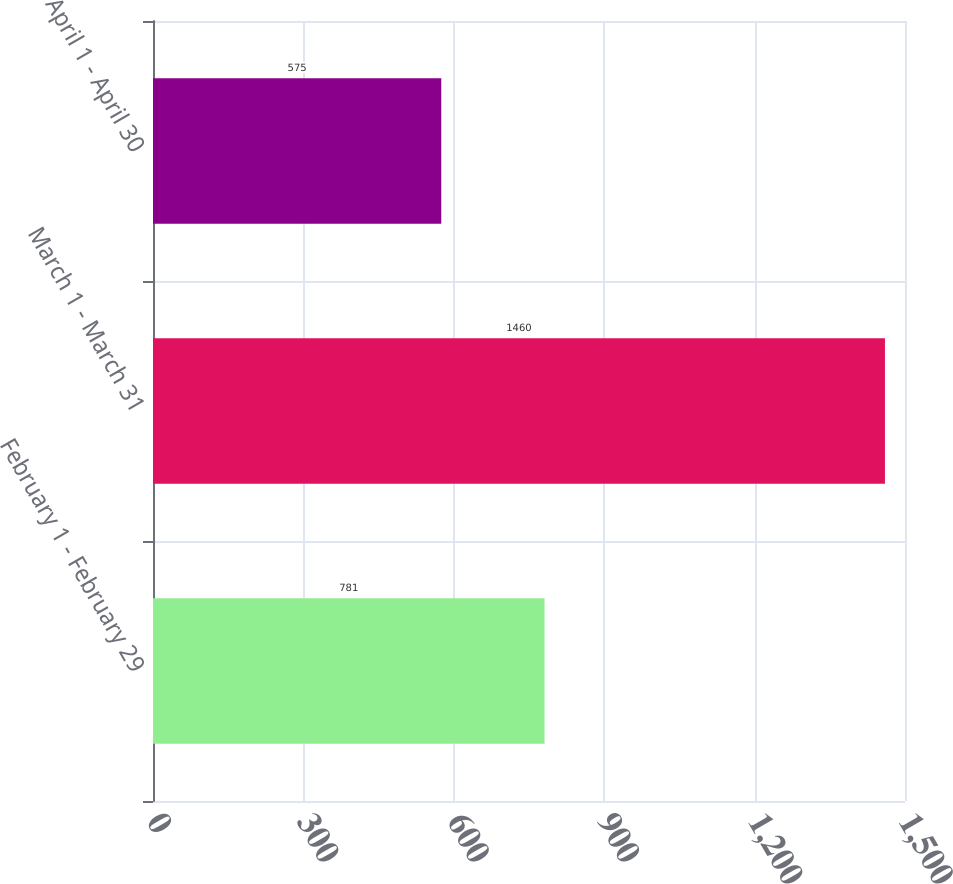Convert chart to OTSL. <chart><loc_0><loc_0><loc_500><loc_500><bar_chart><fcel>February 1 - February 29<fcel>March 1 - March 31<fcel>April 1 - April 30<nl><fcel>781<fcel>1460<fcel>575<nl></chart> 